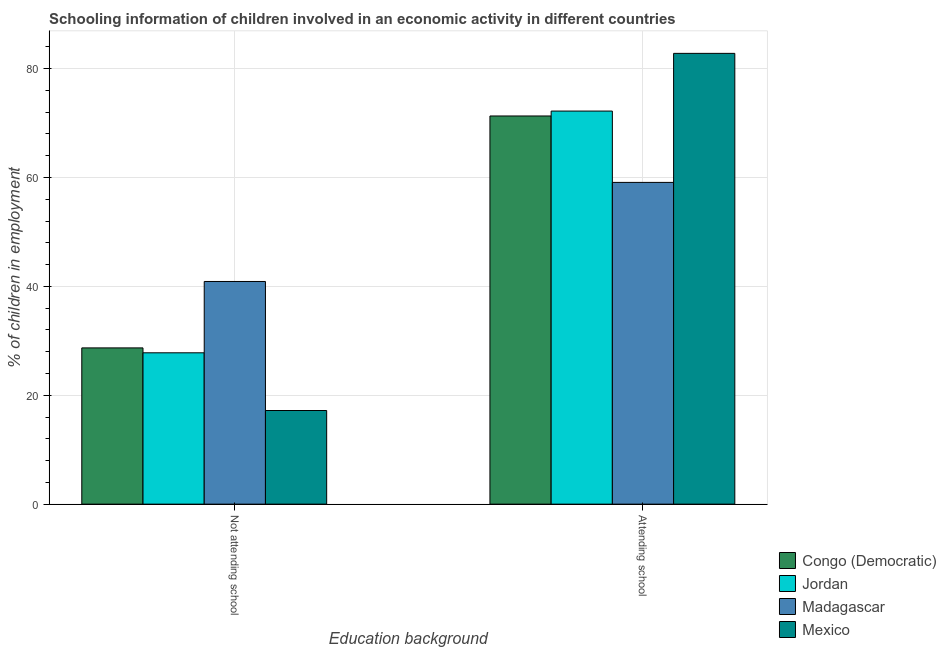How many different coloured bars are there?
Provide a short and direct response. 4. Are the number of bars per tick equal to the number of legend labels?
Offer a terse response. Yes. How many bars are there on the 2nd tick from the left?
Give a very brief answer. 4. What is the label of the 2nd group of bars from the left?
Offer a very short reply. Attending school. What is the percentage of employed children who are not attending school in Jordan?
Give a very brief answer. 27.8. Across all countries, what is the maximum percentage of employed children who are not attending school?
Provide a succinct answer. 40.9. Across all countries, what is the minimum percentage of employed children who are not attending school?
Give a very brief answer. 17.2. In which country was the percentage of employed children who are not attending school maximum?
Provide a short and direct response. Madagascar. In which country was the percentage of employed children who are not attending school minimum?
Your response must be concise. Mexico. What is the total percentage of employed children who are not attending school in the graph?
Provide a succinct answer. 114.6. What is the difference between the percentage of employed children who are not attending school in Madagascar and the percentage of employed children who are attending school in Jordan?
Your answer should be compact. -31.3. What is the average percentage of employed children who are attending school per country?
Provide a succinct answer. 71.35. What is the difference between the percentage of employed children who are not attending school and percentage of employed children who are attending school in Jordan?
Provide a succinct answer. -44.4. What is the ratio of the percentage of employed children who are attending school in Jordan to that in Mexico?
Your answer should be compact. 0.87. What does the 2nd bar from the left in Not attending school represents?
Provide a succinct answer. Jordan. What does the 3rd bar from the right in Attending school represents?
Give a very brief answer. Jordan. How many bars are there?
Provide a succinct answer. 8. Are all the bars in the graph horizontal?
Provide a short and direct response. No. What is the difference between two consecutive major ticks on the Y-axis?
Ensure brevity in your answer.  20. Does the graph contain grids?
Your answer should be compact. Yes. Where does the legend appear in the graph?
Offer a very short reply. Bottom right. What is the title of the graph?
Ensure brevity in your answer.  Schooling information of children involved in an economic activity in different countries. What is the label or title of the X-axis?
Give a very brief answer. Education background. What is the label or title of the Y-axis?
Your answer should be very brief. % of children in employment. What is the % of children in employment in Congo (Democratic) in Not attending school?
Give a very brief answer. 28.7. What is the % of children in employment in Jordan in Not attending school?
Your response must be concise. 27.8. What is the % of children in employment in Madagascar in Not attending school?
Your answer should be compact. 40.9. What is the % of children in employment of Congo (Democratic) in Attending school?
Your answer should be very brief. 71.3. What is the % of children in employment of Jordan in Attending school?
Keep it short and to the point. 72.2. What is the % of children in employment in Madagascar in Attending school?
Keep it short and to the point. 59.1. What is the % of children in employment of Mexico in Attending school?
Offer a terse response. 82.8. Across all Education background, what is the maximum % of children in employment in Congo (Democratic)?
Your answer should be compact. 71.3. Across all Education background, what is the maximum % of children in employment in Jordan?
Provide a succinct answer. 72.2. Across all Education background, what is the maximum % of children in employment of Madagascar?
Provide a succinct answer. 59.1. Across all Education background, what is the maximum % of children in employment of Mexico?
Provide a short and direct response. 82.8. Across all Education background, what is the minimum % of children in employment of Congo (Democratic)?
Keep it short and to the point. 28.7. Across all Education background, what is the minimum % of children in employment in Jordan?
Your response must be concise. 27.8. Across all Education background, what is the minimum % of children in employment of Madagascar?
Make the answer very short. 40.9. What is the total % of children in employment in Congo (Democratic) in the graph?
Your response must be concise. 100. What is the total % of children in employment in Mexico in the graph?
Make the answer very short. 100. What is the difference between the % of children in employment of Congo (Democratic) in Not attending school and that in Attending school?
Your answer should be compact. -42.6. What is the difference between the % of children in employment in Jordan in Not attending school and that in Attending school?
Ensure brevity in your answer.  -44.4. What is the difference between the % of children in employment of Madagascar in Not attending school and that in Attending school?
Your response must be concise. -18.2. What is the difference between the % of children in employment in Mexico in Not attending school and that in Attending school?
Your response must be concise. -65.6. What is the difference between the % of children in employment in Congo (Democratic) in Not attending school and the % of children in employment in Jordan in Attending school?
Ensure brevity in your answer.  -43.5. What is the difference between the % of children in employment of Congo (Democratic) in Not attending school and the % of children in employment of Madagascar in Attending school?
Your response must be concise. -30.4. What is the difference between the % of children in employment of Congo (Democratic) in Not attending school and the % of children in employment of Mexico in Attending school?
Ensure brevity in your answer.  -54.1. What is the difference between the % of children in employment in Jordan in Not attending school and the % of children in employment in Madagascar in Attending school?
Offer a very short reply. -31.3. What is the difference between the % of children in employment in Jordan in Not attending school and the % of children in employment in Mexico in Attending school?
Your answer should be very brief. -55. What is the difference between the % of children in employment of Madagascar in Not attending school and the % of children in employment of Mexico in Attending school?
Offer a terse response. -41.9. What is the average % of children in employment in Congo (Democratic) per Education background?
Offer a very short reply. 50. What is the average % of children in employment of Jordan per Education background?
Provide a succinct answer. 50. What is the average % of children in employment in Mexico per Education background?
Offer a very short reply. 50. What is the difference between the % of children in employment in Congo (Democratic) and % of children in employment in Mexico in Not attending school?
Give a very brief answer. 11.5. What is the difference between the % of children in employment in Jordan and % of children in employment in Madagascar in Not attending school?
Offer a terse response. -13.1. What is the difference between the % of children in employment of Madagascar and % of children in employment of Mexico in Not attending school?
Make the answer very short. 23.7. What is the difference between the % of children in employment in Congo (Democratic) and % of children in employment in Jordan in Attending school?
Your response must be concise. -0.9. What is the difference between the % of children in employment of Jordan and % of children in employment of Madagascar in Attending school?
Your response must be concise. 13.1. What is the difference between the % of children in employment in Madagascar and % of children in employment in Mexico in Attending school?
Keep it short and to the point. -23.7. What is the ratio of the % of children in employment of Congo (Democratic) in Not attending school to that in Attending school?
Provide a succinct answer. 0.4. What is the ratio of the % of children in employment in Jordan in Not attending school to that in Attending school?
Your answer should be compact. 0.39. What is the ratio of the % of children in employment of Madagascar in Not attending school to that in Attending school?
Offer a very short reply. 0.69. What is the ratio of the % of children in employment in Mexico in Not attending school to that in Attending school?
Give a very brief answer. 0.21. What is the difference between the highest and the second highest % of children in employment in Congo (Democratic)?
Offer a terse response. 42.6. What is the difference between the highest and the second highest % of children in employment in Jordan?
Your answer should be very brief. 44.4. What is the difference between the highest and the second highest % of children in employment of Mexico?
Make the answer very short. 65.6. What is the difference between the highest and the lowest % of children in employment in Congo (Democratic)?
Your response must be concise. 42.6. What is the difference between the highest and the lowest % of children in employment of Jordan?
Offer a terse response. 44.4. What is the difference between the highest and the lowest % of children in employment of Madagascar?
Offer a terse response. 18.2. What is the difference between the highest and the lowest % of children in employment in Mexico?
Keep it short and to the point. 65.6. 